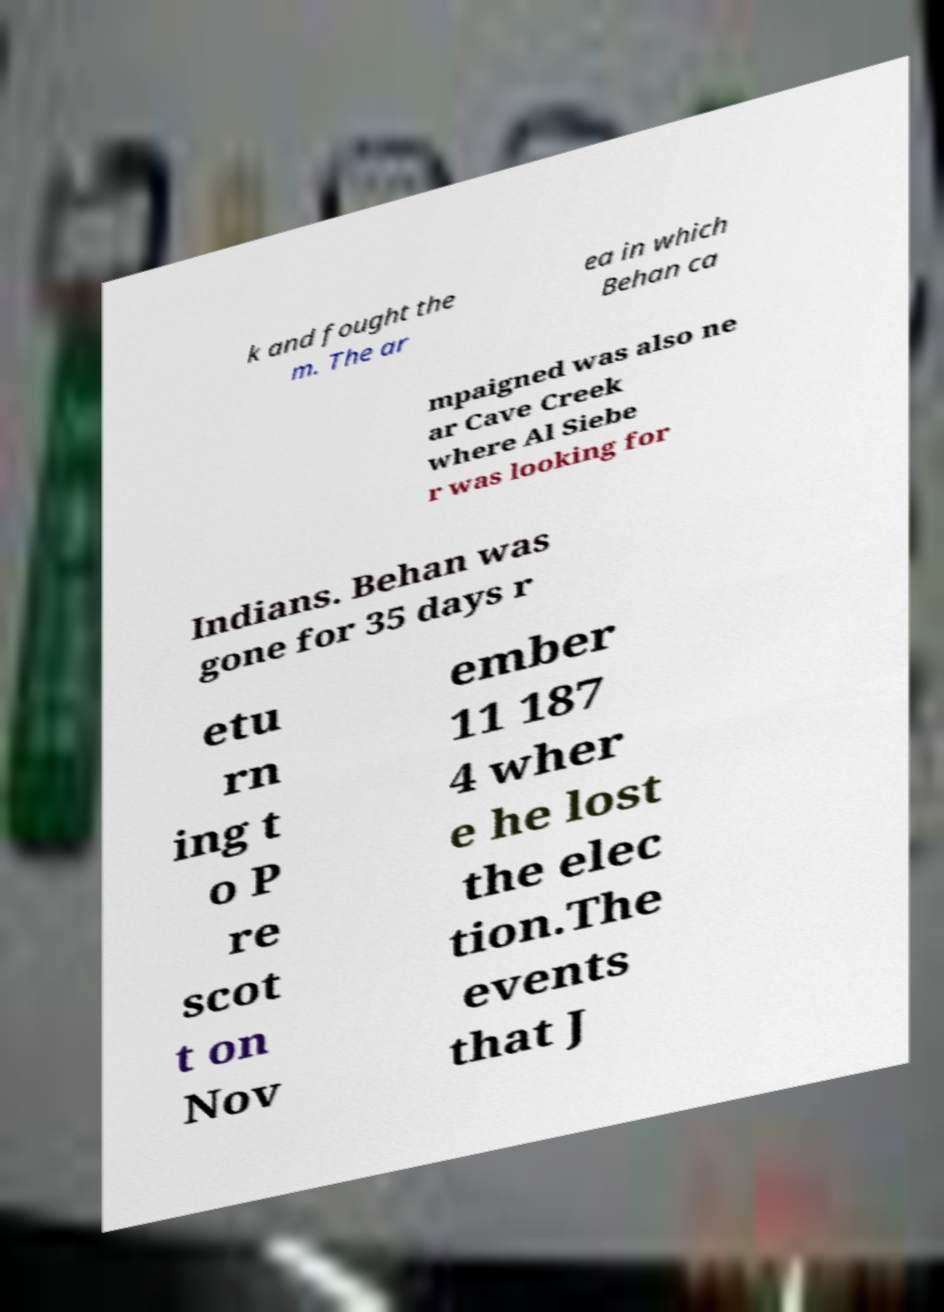For documentation purposes, I need the text within this image transcribed. Could you provide that? k and fought the m. The ar ea in which Behan ca mpaigned was also ne ar Cave Creek where Al Siebe r was looking for Indians. Behan was gone for 35 days r etu rn ing t o P re scot t on Nov ember 11 187 4 wher e he lost the elec tion.The events that J 